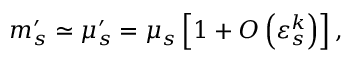<formula> <loc_0><loc_0><loc_500><loc_500>m _ { s } ^ { \prime } \simeq \mu _ { s } ^ { \prime } = \mu _ { s } \left [ 1 + O \left ( \varepsilon _ { s } ^ { k } \right ) \right ] ,</formula> 